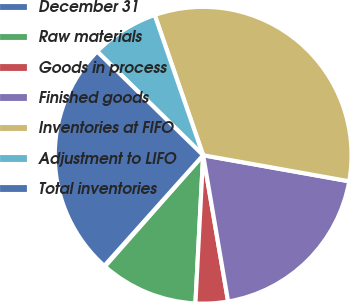Convert chart to OTSL. <chart><loc_0><loc_0><loc_500><loc_500><pie_chart><fcel>December 31<fcel>Raw materials<fcel>Goods in process<fcel>Finished goods<fcel>Inventories at FIFO<fcel>Adjustment to LIFO<fcel>Total inventories<nl><fcel>0.1%<fcel>10.68%<fcel>3.52%<fcel>19.5%<fcel>33.1%<fcel>7.38%<fcel>25.72%<nl></chart> 